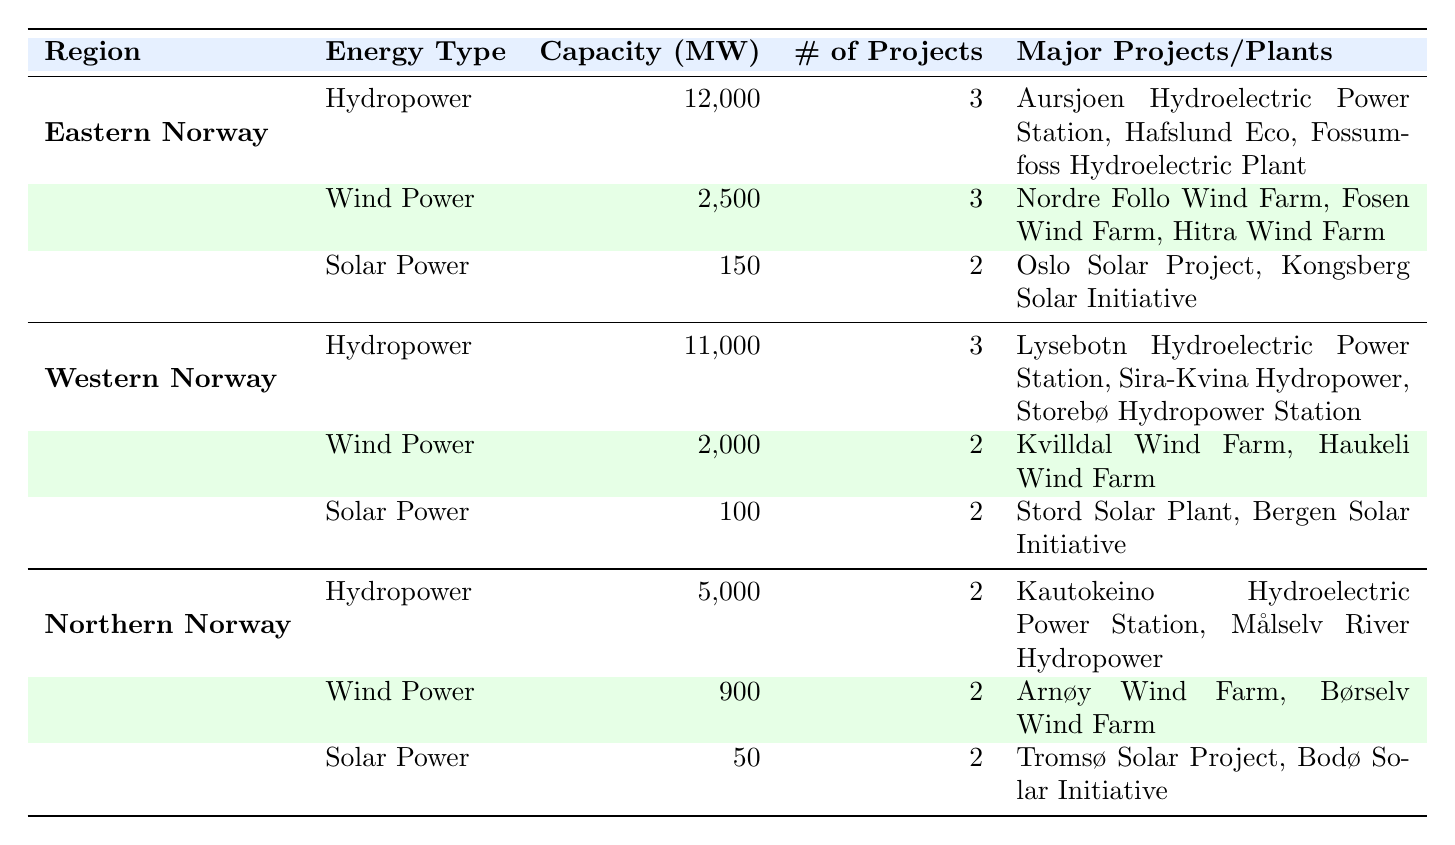What is the total hydropower capacity in Norway? Adding the hydropower capacities from each region: Eastern Norway (12000 MW) + Western Norway (11000 MW) + Northern Norway (5000 MW) = 28000 MW
Answer: 28000 MW Which region has the highest capacity for wind power? Comparing the wind power capacities: Eastern Norway (2500 MW), Western Norway (2000 MW), and Northern Norway (900 MW). Eastern Norway has the highest at 2500 MW.
Answer: Eastern Norway Is there more solar power capacity in Western Norway than in Northern Norway? The solar power capacity in Western Norway is 100 MW, while in Northern Norway it is 50 MW. Since 100 is greater than 50, the statement is true.
Answer: Yes How many major hydropower plants are there in Eastern Norway? The table lists 3 major hydropower plants in Eastern Norway: Aursjoen Hydroelectric Power Station, Hafslund Eco, and Fossumfoss Hydroelectric Plant.
Answer: 3 What is the average capacity of wind power across the three regions? The wind power capacities are 2500 MW (Eastern Norway), 2000 MW (Western Norway), and 900 MW (Northern Norway). The total is 2500 + 2000 + 900 = 5400 MW. The average is 5400 MW / 3 = 1800 MW.
Answer: 1800 MW Are there equal numbers of major solar power installations in all regions? Checking the counts: Eastern Norway has 2 installations, Western Norway has 2 installations, and Northern Norway has 2 installations. Since all regions have the same count, the statement is true.
Answer: Yes Which region has the smallest capacity for solar power? Looking at the solar power capacities: Eastern Norway (150 MW), Western Norway (100 MW), Northern Norway (50 MW). Northern Norway has the smallest capacity at 50 MW.
Answer: Northern Norway What is the total capacity of renewable energy (hydropower, wind power, and solar power) in Western Norway? To find the total, add the capacities: Hydropower (11000 MW) + Wind Power (2000 MW) + Solar Power (100 MW) = 13200 MW.
Answer: 13200 MW Which energy type has the lowest capacity in Northern Norway? Comparing the capacities in Northern Norway: Hydropower (5000 MW), Wind Power (900 MW), and Solar Power (50 MW). Solar Power has the lowest capacity at 50 MW.
Answer: Solar Power 